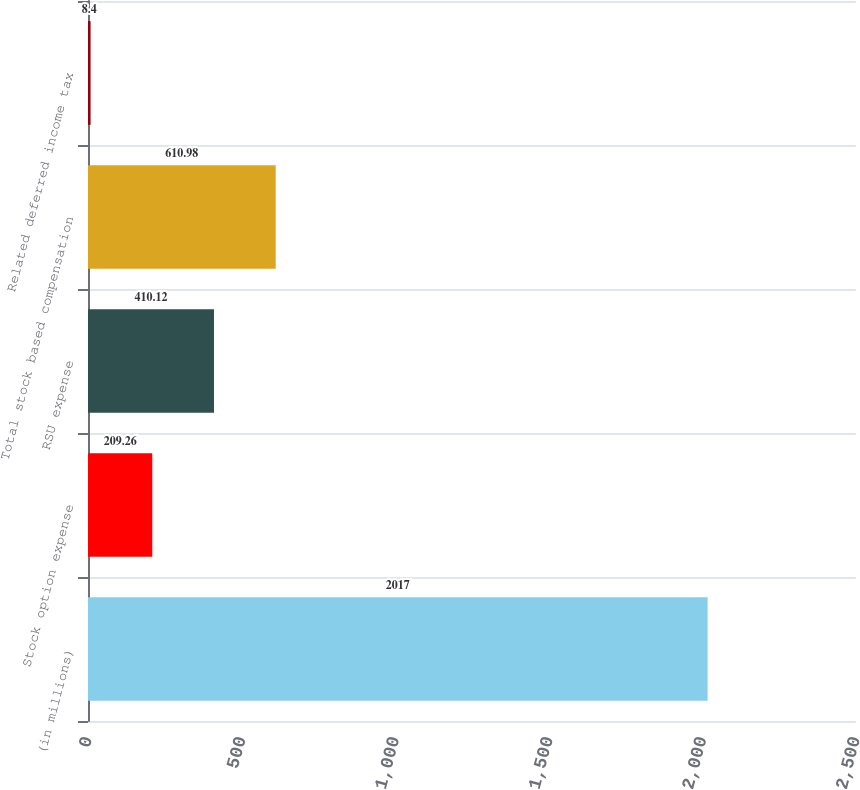<chart> <loc_0><loc_0><loc_500><loc_500><bar_chart><fcel>(in millions)<fcel>Stock option expense<fcel>RSU expense<fcel>Total stock based compensation<fcel>Related deferred income tax<nl><fcel>2017<fcel>209.26<fcel>410.12<fcel>610.98<fcel>8.4<nl></chart> 